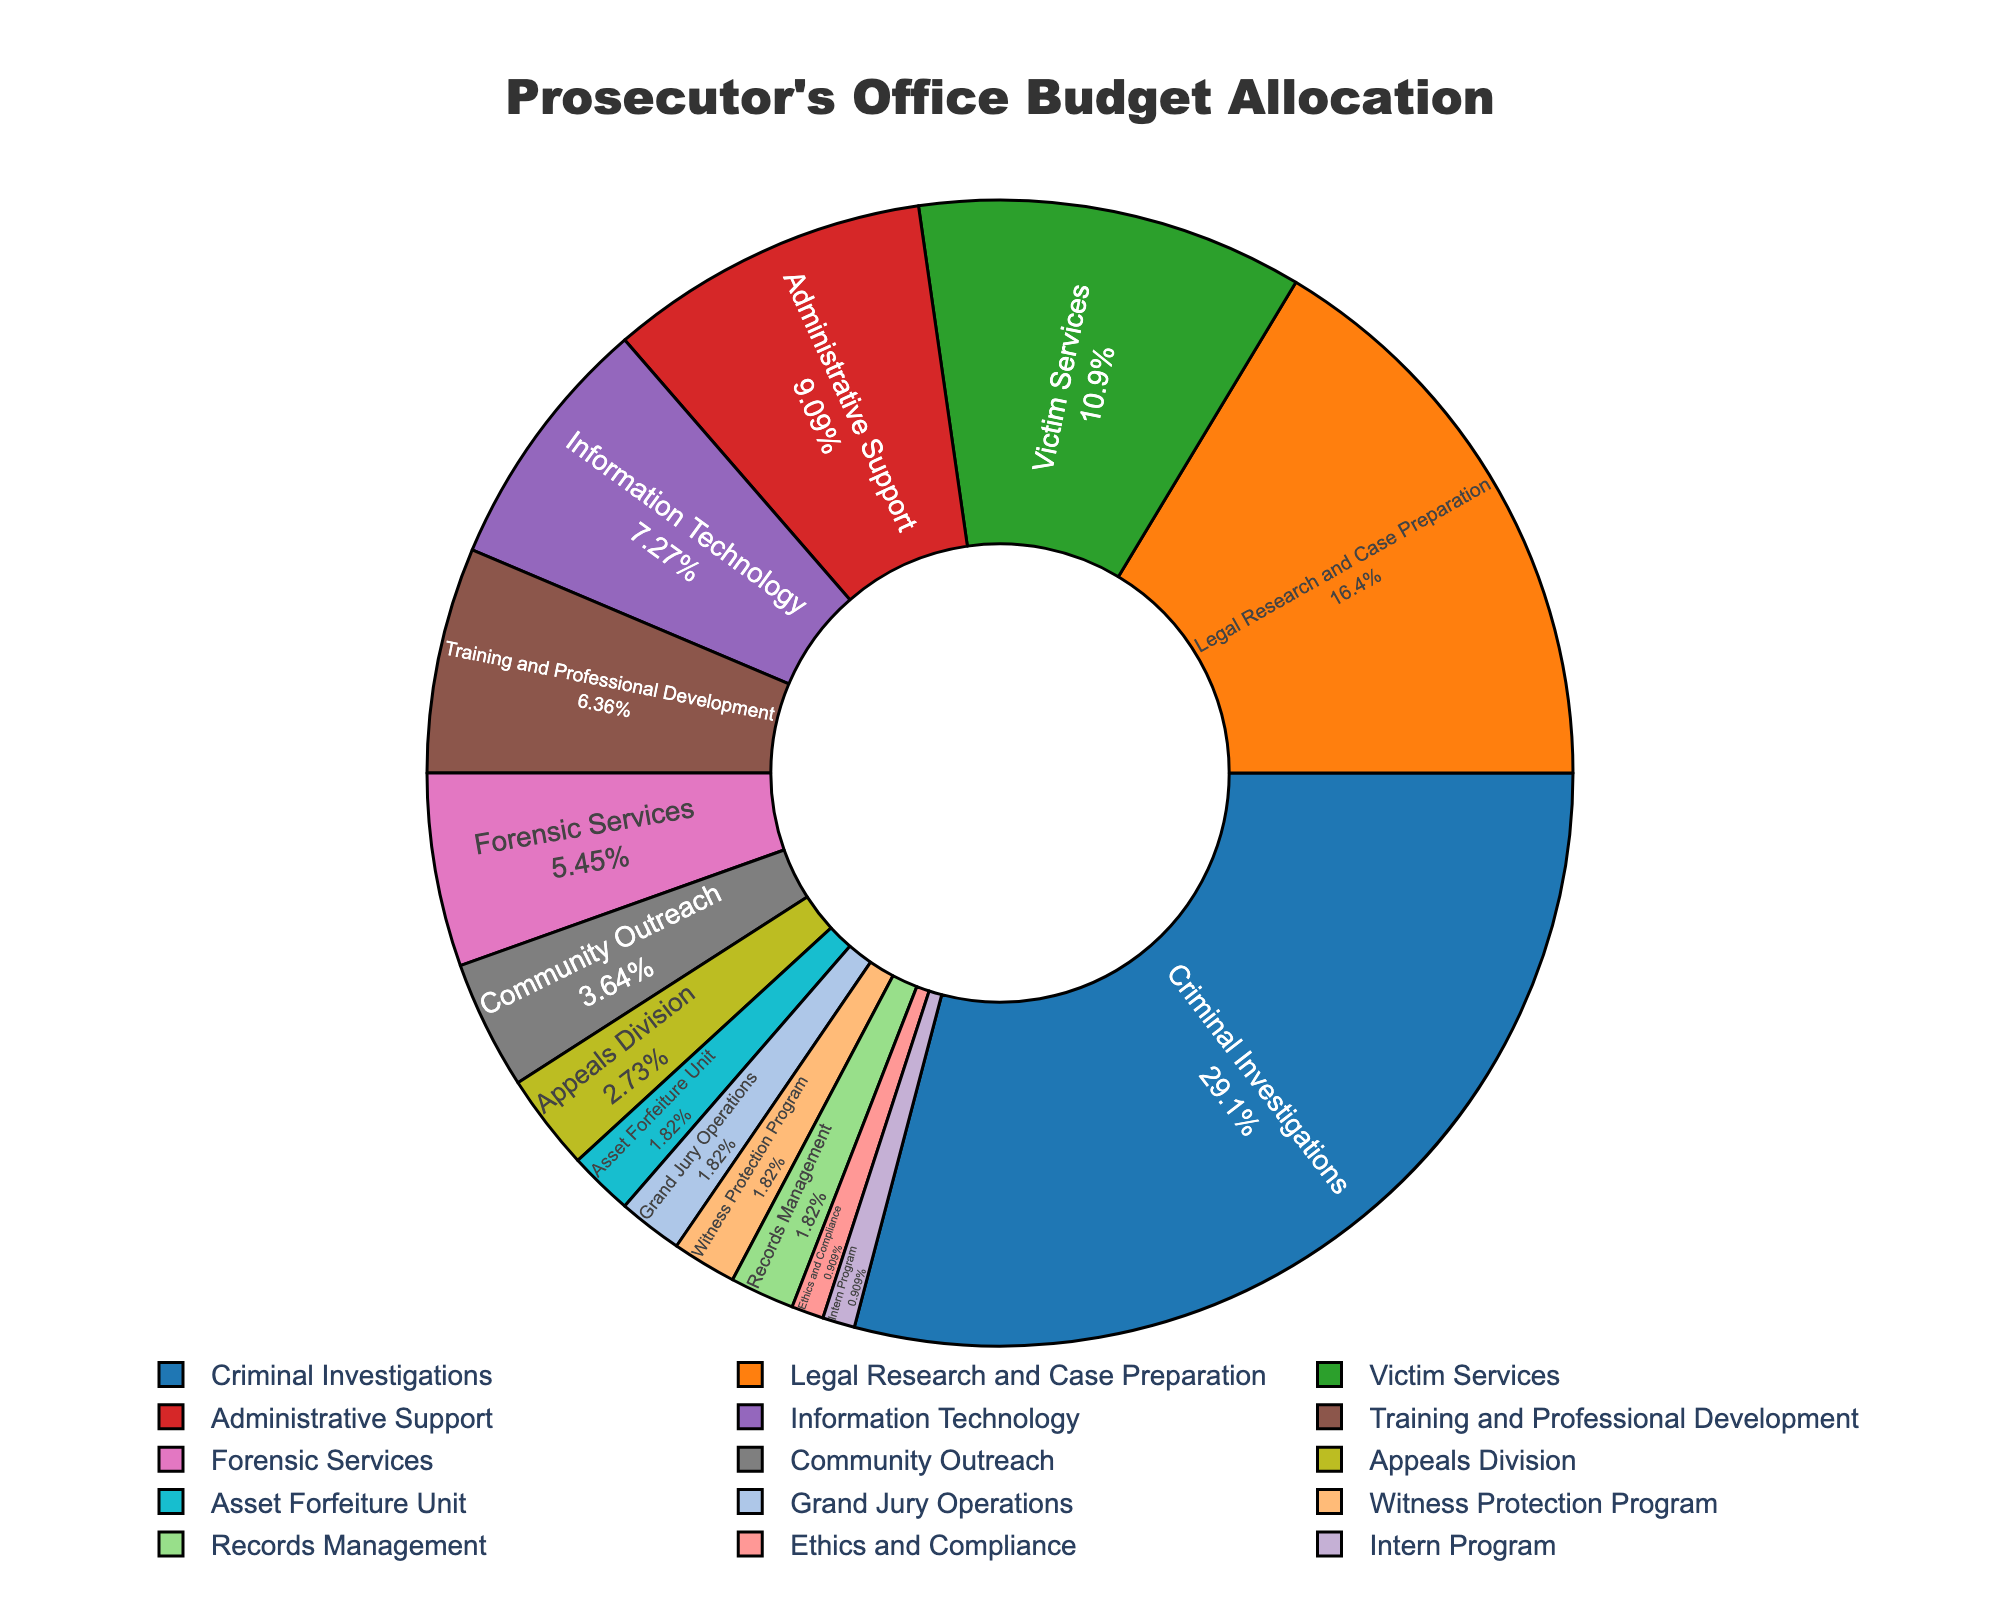Which department receives the largest portion of the budget allocation? The department with the largest portion of the budget allocation is labeled as such in the pie chart, showing the highest percentage.
Answer: Criminal Investigations What is the combined budget allocation for Administrative Support and Information Technology? Sum the percentage values for both Administrative Support and Information Technology. Administrative Support (10%) + Information Technology (8%) = 18%
Answer: 18% Are Victim Services allocated more budget than Legal Research and Case Preparation? Compare the budget allocations of Victim Services and Legal Research and Case Preparation. Victim Services have 12%, while Legal Research and Case Preparation have 18%.
Answer: No What is the difference in budget allocation between Training and Professional Development and Forensic Services? Subtract the budget allocation of Forensic Services from that of Training and Professional Development. Training and Professional Development (7%) - Forensic Services (6%) = 1%
Answer: 1% Which departments each receive exactly 2% of the budget? Identify the departments labeled with 2% in the pie chart.
Answer: Asset Forfeiture Unit, Grand Jury Operations, Witness Protection Program, Records Management How does the budget for Community Outreach compare to that of the Appeals Division? Check the percentages for Community Outreach and Appeals Division in the pie chart. Community Outreach has 4%, and Appeals Division has 3%.
Answer: Community Outreach has a higher budget What is the total budget allocation for departments that receive less than 5% each? Sum the percentages for all departments with less than 5% allocation: Appeals Division (3%) + Asset Forfeiture Unit (2%) + Grand Jury Operations (2%) + Witness Protection Program (2%) + Records Management (2%) + Ethics and Compliance (1%) + Intern Program (1%) = 13%
Answer: 13% Which department is visualized using the green color in the pie chart? Identify the segment colored in green.
Answer: Training and Professional Development What is the average budget allocation for the departments receiving exactly 1% of the total budget? Both Ethics and Compliance and Intern Program receive 1%. The average is calculated as (1% + 1%) / 2 = 1%
Answer: 1% Is the combined budget allocation of Criminal Investigations and Legal Research and Case Preparation greater than or equal to 50%? Sum Criminal Investigations (32%) and Legal Research and Case Preparation (18%): 32% + 18% = 50%.
Answer: Yes 